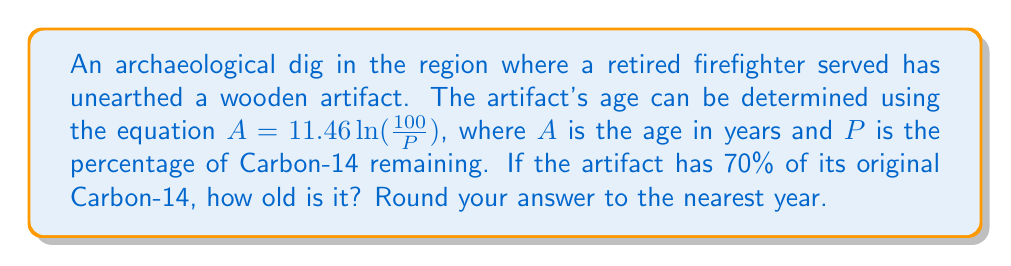Give your solution to this math problem. To solve this problem, we'll follow these steps:

1) We're given the equation: $A = 11.46 \ln(\frac{100}{P})$
   Where $A$ is the age in years and $P$ is the percentage of Carbon-14 remaining.

2) We know that $P = 70$ (70% of Carbon-14 remains)

3) Let's substitute this into our equation:

   $A = 11.46 \ln(\frac{100}{70})$

4) Now we can solve this step-by-step:
   
   $A = 11.46 \ln(1.4285714...)$
   
   $A = 11.46 \times 0.3566749...$
   
   $A = 4.0875204...$

5) Rounding to the nearest year:

   $A \approx 4$ years

Therefore, the artifact is approximately 4 years old.
Answer: 4 years 